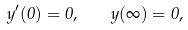<formula> <loc_0><loc_0><loc_500><loc_500>y ^ { \prime } ( 0 ) = 0 , \quad y ( \infty ) = 0 ,</formula> 